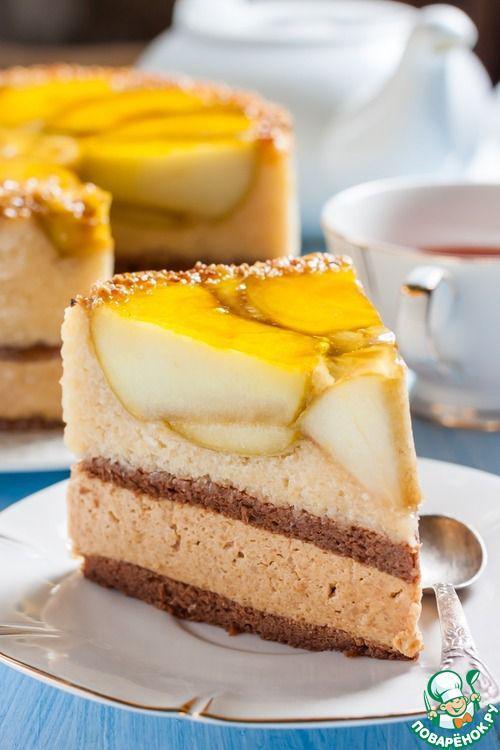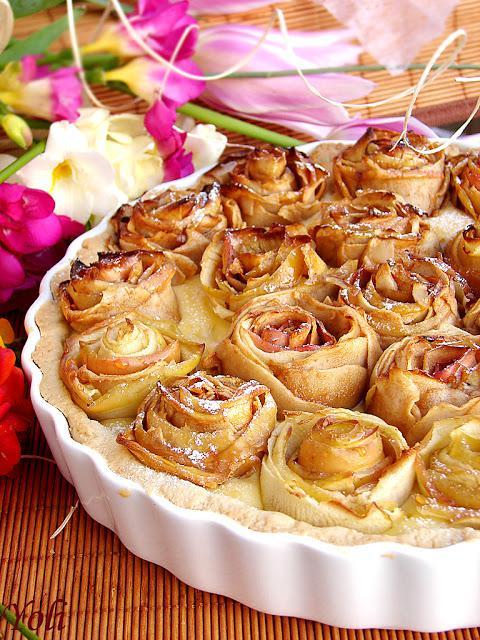The first image is the image on the left, the second image is the image on the right. For the images displayed, is the sentence "The left image shows one pie slice on a white plate, and the right image shows a pie with a slice missing and includes an individual slice." factually correct? Answer yes or no. No. The first image is the image on the left, the second image is the image on the right. Evaluate the accuracy of this statement regarding the images: "There is one whole pie.". Is it true? Answer yes or no. Yes. 